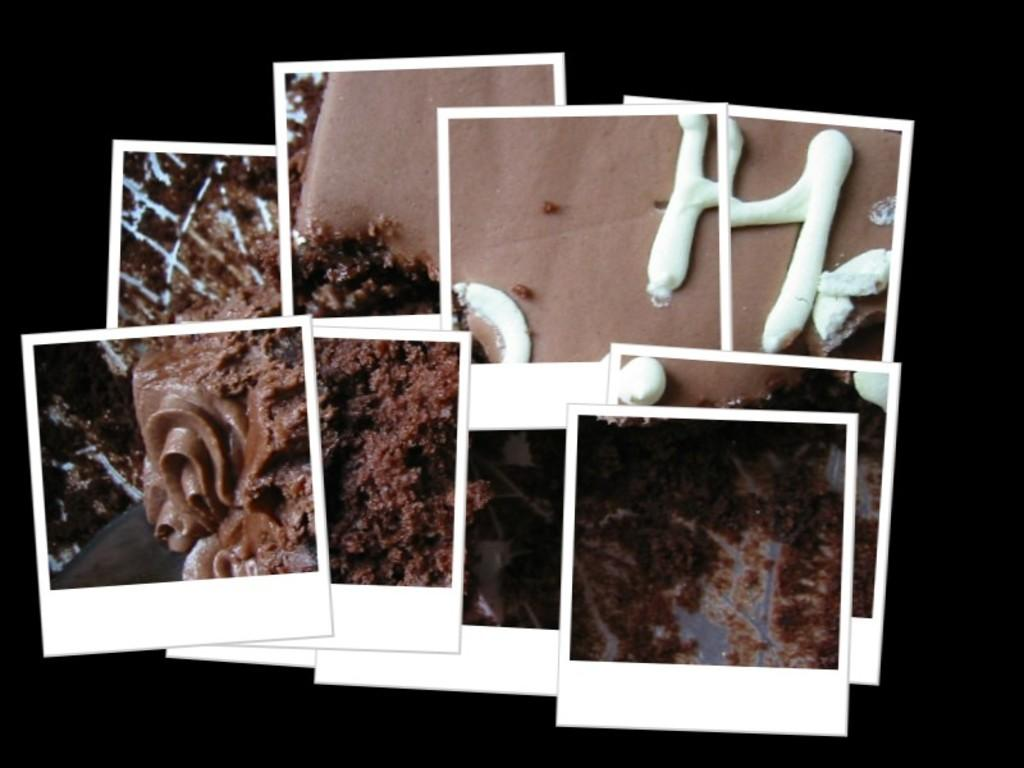What is the main subject of the image? The main subject of the image is a collage of photos. Can you describe any specific elements within the collage? Yes, the photos in the collage include a cake. What color is the background of the image? The background of the image appears to be black. What type of ink is used to write on the kite in the image? There is no kite present in the image, so it is not possible to determine what type of ink might be used to write on it. 